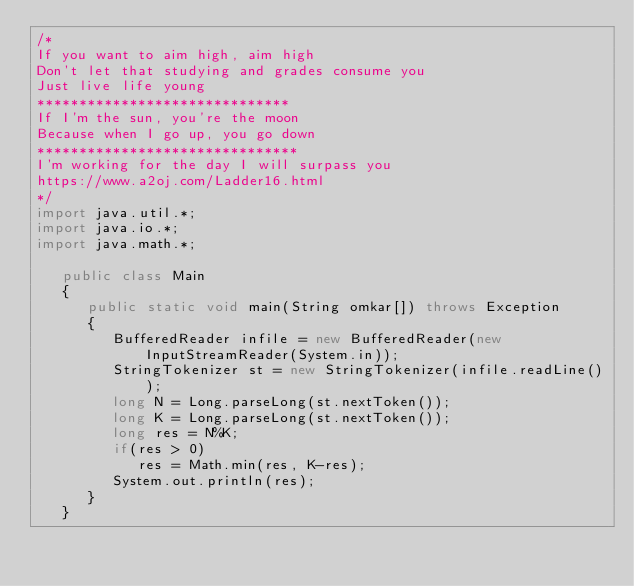Convert code to text. <code><loc_0><loc_0><loc_500><loc_500><_Java_>/*
If you want to aim high, aim high
Don't let that studying and grades consume you
Just live life young
******************************
If I'm the sun, you're the moon
Because when I go up, you go down
*******************************
I'm working for the day I will surpass you
https://www.a2oj.com/Ladder16.html
*/
import java.util.*;
import java.io.*;
import java.math.*;

   public class Main
   {
      public static void main(String omkar[]) throws Exception
      {
         BufferedReader infile = new BufferedReader(new InputStreamReader(System.in));  
         StringTokenizer st = new StringTokenizer(infile.readLine());
         long N = Long.parseLong(st.nextToken());
         long K = Long.parseLong(st.nextToken());
         long res = N%K;
         if(res > 0)
            res = Math.min(res, K-res);
         System.out.println(res);
      }
   }</code> 